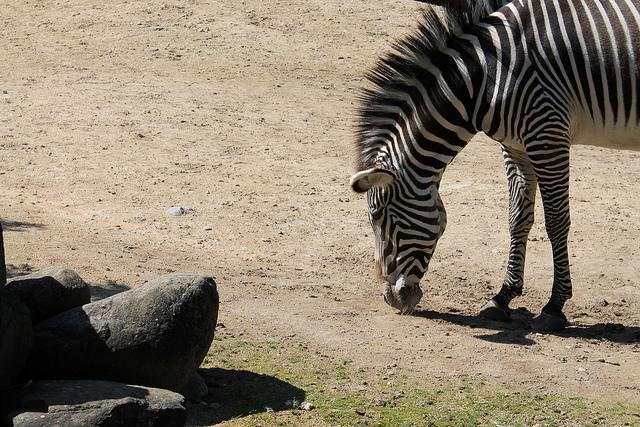How many zebras?
Give a very brief answer. 1. How many different animals are in this picture?
Give a very brief answer. 1. 